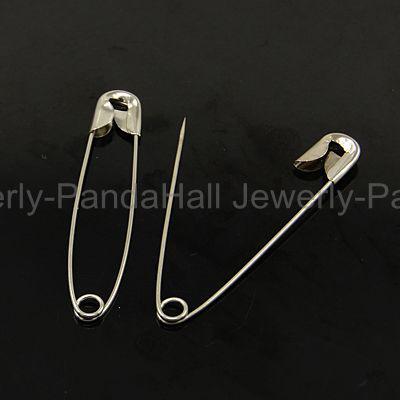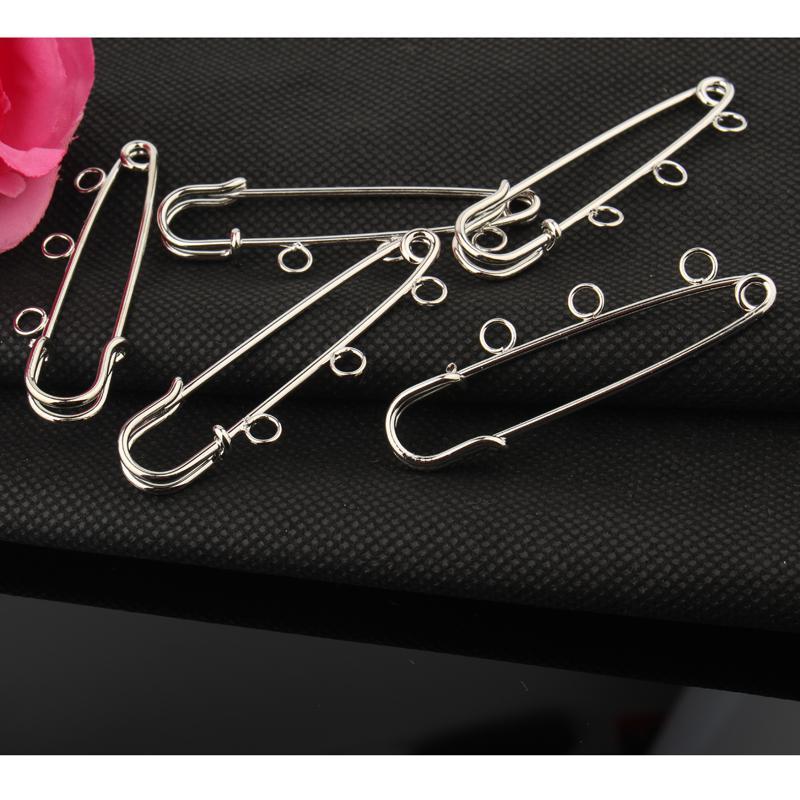The first image is the image on the left, the second image is the image on the right. Considering the images on both sides, is "There are at least four pins in the image on the right." valid? Answer yes or no. Yes. 